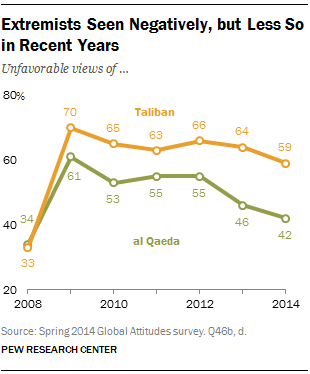List a handful of essential elements in this visual. The highest value in Al Qaeda is 61. The color orange in the graph is representative of the Taliban. 